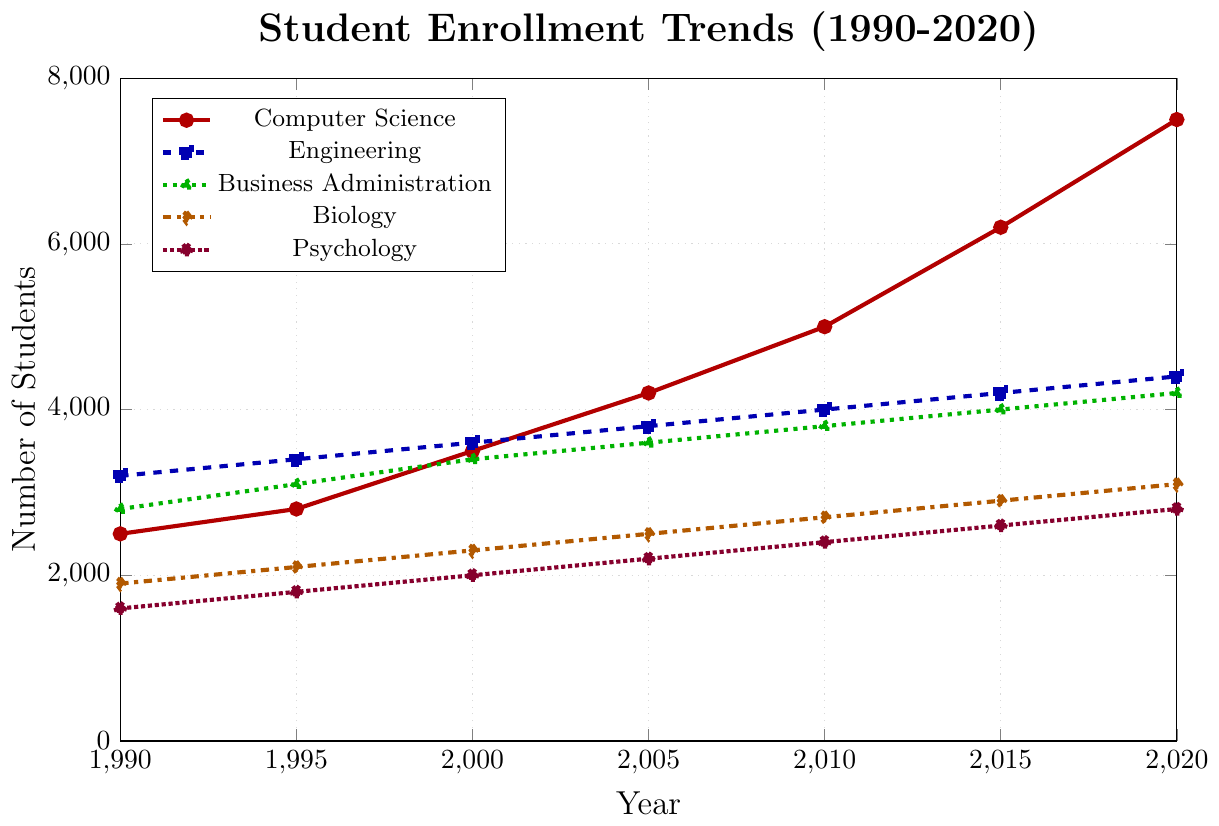What year did Computer Science student enrollment first exceed 4000? Looking at the trend of Computer Science enrollment, the first point exceeding 4000 is at the year 2005.
Answer: 2005 Compare the growth rates of student enrollment in Computer Science and Engineering from 1990 to 2020. From 1990 to 2020, Computer Science grew from 2500 to 7500, an increase of 5000. Engineering grew from 3200 to 4400, an increase of 1200. Thus, Computer Science had a larger growth.
Answer: Computer Science Which degree program had the slowest growth rate over the three decades? By checking the initial and final enrollments for each degree program, Engineering grew the least from 3200 to 4400, an increase of 1200.
Answer: Engineering What is the difference in student enrollment between Business Administration and Psychology in 2020? The student enrollment in 2020 for Business Administration is 4200 and for Psychology is 2800, hence the difference is 4200 - 2800.
Answer: 1400 Which program shows the highest enrollment in any given year? In 2020, Computer Science had the highest enrollment at 7500.
Answer: Computer Science Estimate the average annual increase in student enrollment for Biology between 1990 and 2020. Initial enrollment for Biology in 1990 is 1900 and in 2020 is 3100. The increase over 30 years is 3100 - 1900 = 1200. The average annual increase is 1200 / 30 years.
Answer: 40 Compare the enrollments of Psychology in 2000 and 2020. In 2000, the enrollment for Psychology is 2000 and in 2020 it is 2800.
Answer: 800 Identify the color representing Business Administration in the figure. Business Administration is represented by a green, dotted line with triangle markers, based on the cycle list.
Answer: green How does the enrollment trend for Engineering between 1990 and 2005 compare to its trend between 2005 and 2020? Between 1990 and 2005, Engineering enrollment grew from 3200 to 3800, an increase of 600. From 2005 to 2020, it grew from 3800 to 4400, an increase of 600. The growth rates are similar over the two periods.
Answer: Similar In 2015, which degree program had the least number of students, and how many were enrolled in that program? In 2015, Psychology had the least number of students with an enrollment of 2600.
Answer: Psychology, 2600 